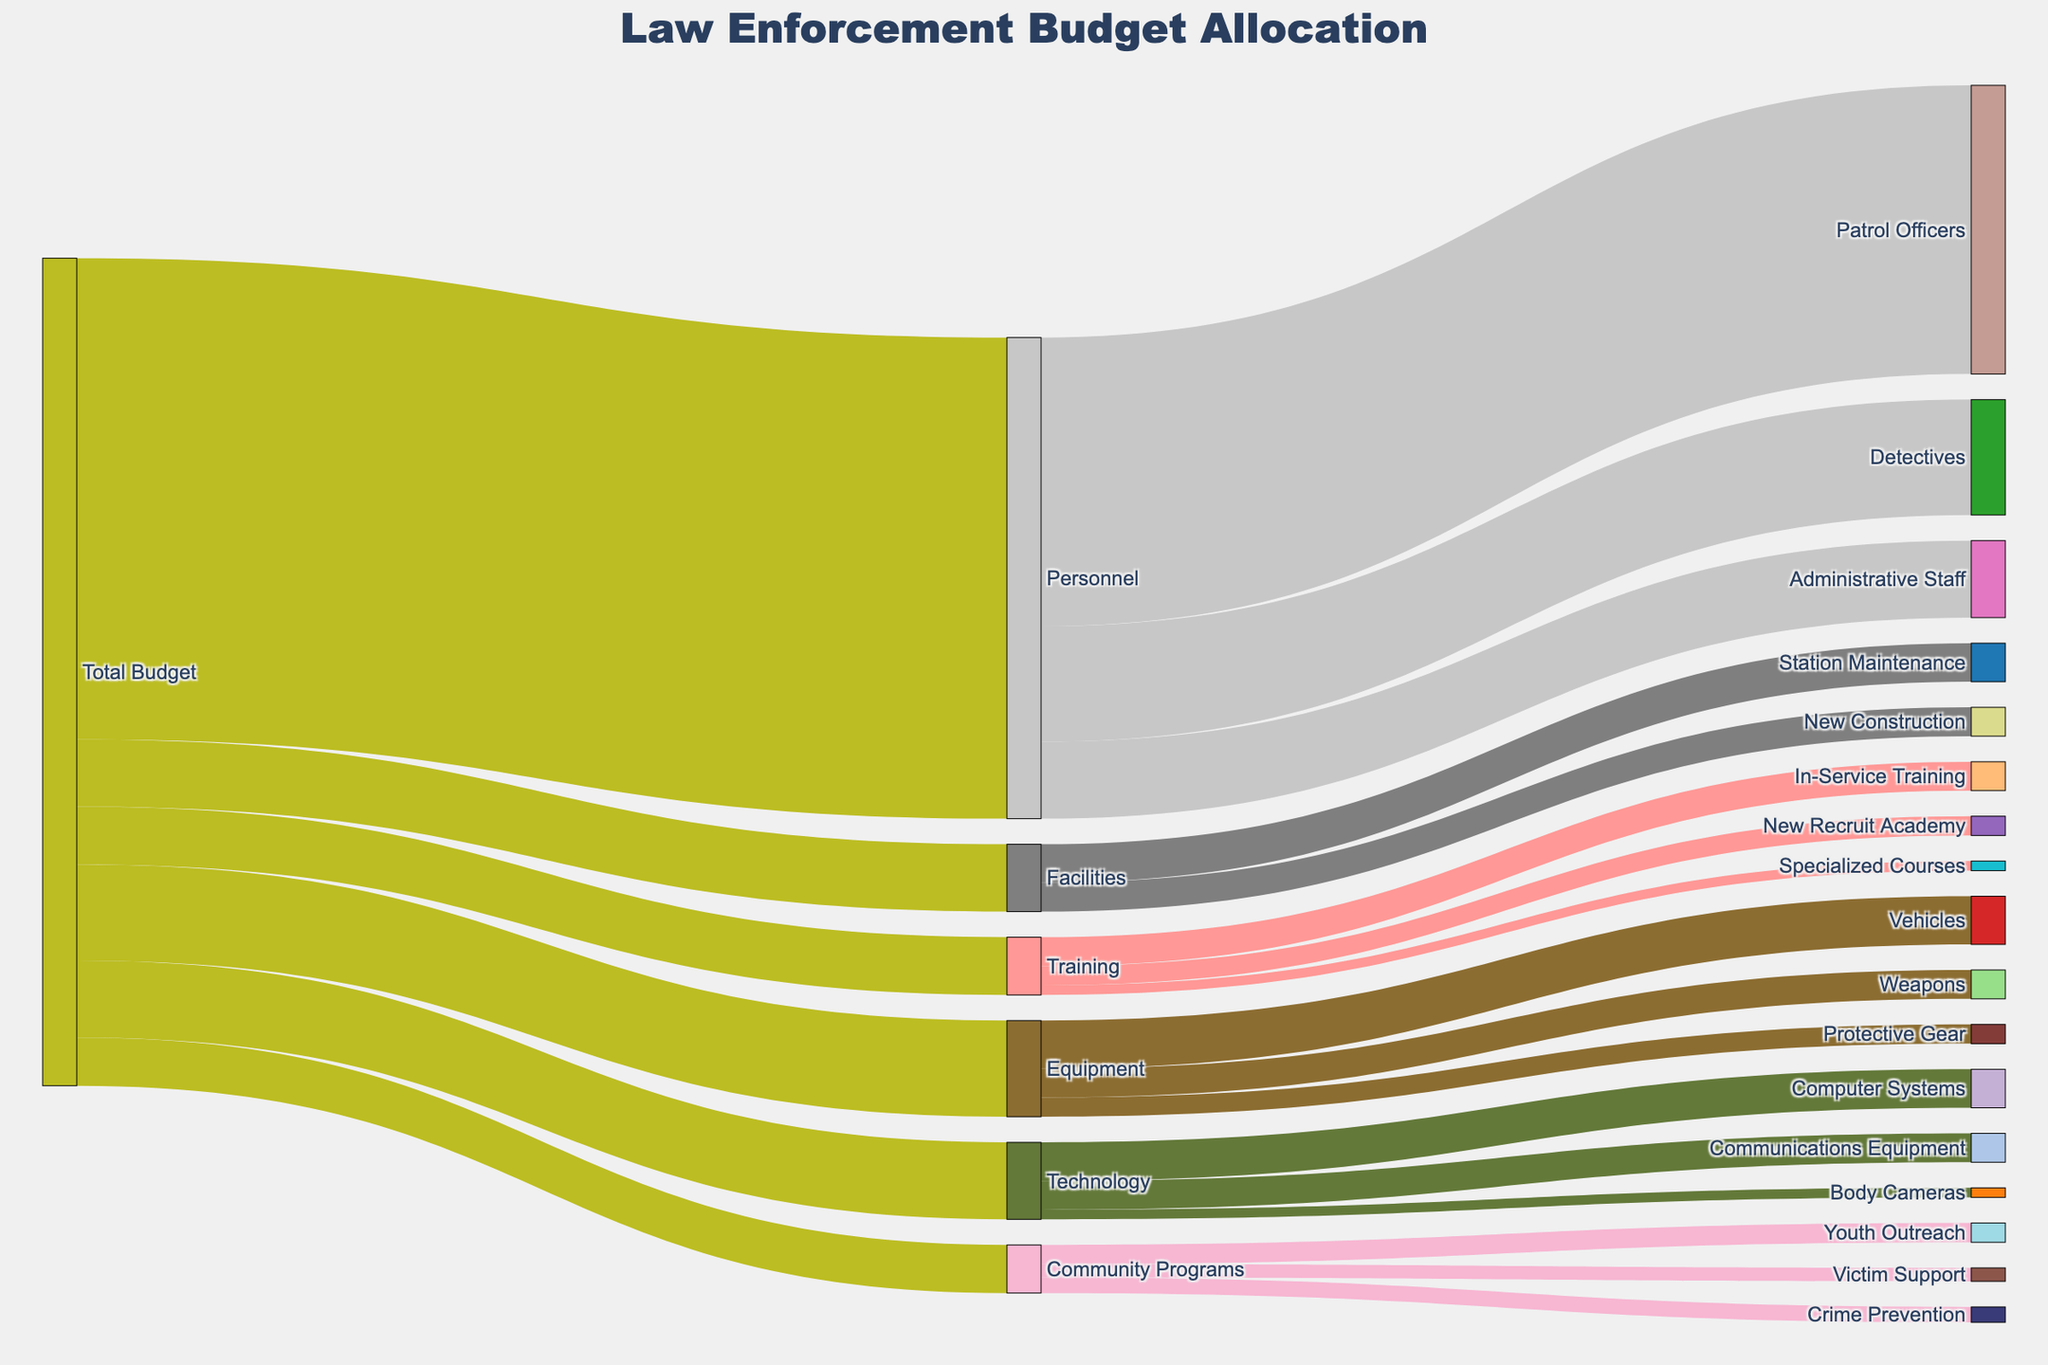What is the total budget allocated for law enforcement? The total budget is represented by the initial allocation to the source category labelled "Total Budget". It connects to multiple targets like Personnel, Equipment, etc., summing up the total budget.
Answer: 430 million How much of the budget is allocated to Equipment? The value connected from "Total Budget" to "Equipment" indicates the allocation for Equipment.
Answer: 50 million Which department under Personnel receives the highest budget? Under the Personnel category, there are multiple sub-categories: Patrol Officers, Detectives, and Administrative Staff. By comparing their values, Patrol Officers receive the highest budget.
Answer: Patrol Officers What percentage of Technology budget is spent on Communications Equipment? First, identify the budget for Technology (40 million). Then, find the allocation for Communications Equipment (15 million). Calculate the percentage: (15 / 40) * 100.
Answer: 37.5% How do the budgets for Station Maintenance and New Construction compare within Facilities? The budgets for Station Maintenance and New Construction are 20 million and 15 million, respectively. By comparing, Station Maintenance has a higher budget.
Answer: Station Maintenance has more What is the combined budget for all community programs? The community programs are Youth Outreach, Crime Prevention, and Victim Support with respective budgets of 10 million, 8 million, and 7 million. Summing these values gives their combined budget. (10 + 8 + 7)
Answer: 25 million Which specific program within Training has the smallest budget allocation? Under the Training category, compare the budgets for In-Service Training, New Recruit Academy, and Specialized Courses. The smallest budget is for Specialized Courses.
Answer: Specialized Courses How much is allocated in total to Personnel, Equipment, and Training combined? The values for Personnel, Equipment, and Training are 250 million, 50 million, and 30 million. Summing these gives the total allocation. (250 + 50 + 30)
Answer: 330 million Is the budget for New Recruit Academy more than for Body Cameras? New Recruit Academy has 10 million allocated while Body Cameras have 5 million. Comparatively, New Recruit Academy has more.
Answer: Yes Which category has the least allocation within the "Total Budget"? Compare the values connected from "Total Budget" to each category (Personnel, Equipment, Training, Technology, Facilities, Community Programs). Community Programs have the lowest allocation.
Answer: Community Programs 